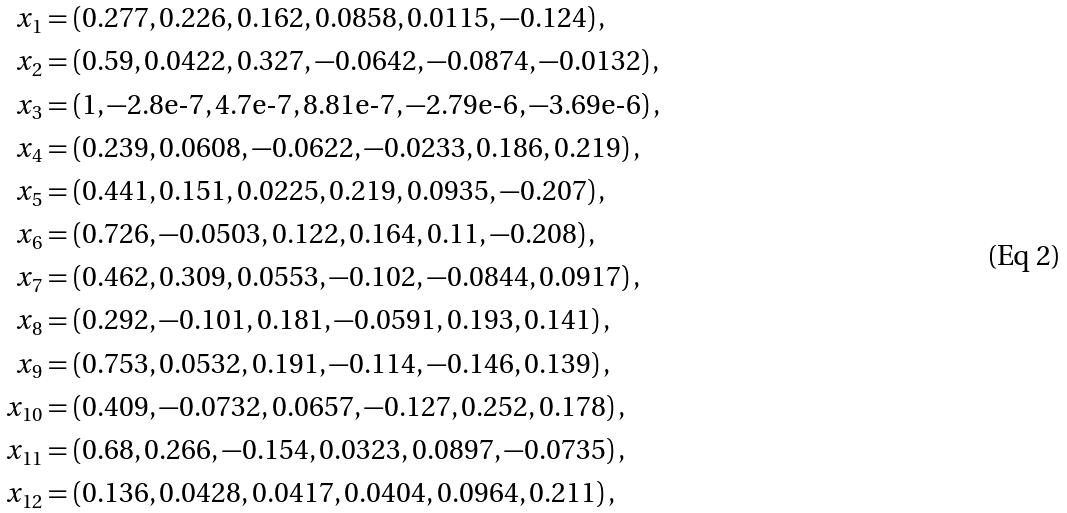<formula> <loc_0><loc_0><loc_500><loc_500>x _ { 1 } & = ( 0 . 2 7 7 , 0 . 2 2 6 , 0 . 1 6 2 , 0 . 0 8 5 8 , 0 . 0 1 1 5 , - 0 . 1 2 4 ) \, , \\ x _ { 2 } & = ( 0 . 5 9 , 0 . 0 4 2 2 , 0 . 3 2 7 , - 0 . 0 6 4 2 , - 0 . 0 8 7 4 , - 0 . 0 1 3 2 ) \, , \\ x _ { 3 } & = ( 1 , - 2 . 8 \text {e-7} , 4 . 7 \text {e-7} , 8 . 8 1 \text {e-7} , - 2 . 7 9 \text {e-6} , - 3 . 6 9 \text {e-6} ) \, , \\ x _ { 4 } & = ( 0 . 2 3 9 , 0 . 0 6 0 8 , - 0 . 0 6 2 2 , - 0 . 0 2 3 3 , 0 . 1 8 6 , 0 . 2 1 9 ) \, , \\ x _ { 5 } & = ( 0 . 4 4 1 , 0 . 1 5 1 , 0 . 0 2 2 5 , 0 . 2 1 9 , 0 . 0 9 3 5 , - 0 . 2 0 7 ) \, , \\ x _ { 6 } & = ( 0 . 7 2 6 , - 0 . 0 5 0 3 , 0 . 1 2 2 , 0 . 1 6 4 , 0 . 1 1 , - 0 . 2 0 8 ) \, , \\ x _ { 7 } & = ( 0 . 4 6 2 , 0 . 3 0 9 , 0 . 0 5 5 3 , - 0 . 1 0 2 , - 0 . 0 8 4 4 , 0 . 0 9 1 7 ) \, , \\ x _ { 8 } & = ( 0 . 2 9 2 , - 0 . 1 0 1 , 0 . 1 8 1 , - 0 . 0 5 9 1 , 0 . 1 9 3 , 0 . 1 4 1 ) \, , \\ x _ { 9 } & = ( 0 . 7 5 3 , 0 . 0 5 3 2 , 0 . 1 9 1 , - 0 . 1 1 4 , - 0 . 1 4 6 , 0 . 1 3 9 ) \, , \\ x _ { 1 0 } & = ( 0 . 4 0 9 , - 0 . 0 7 3 2 , 0 . 0 6 5 7 , - 0 . 1 2 7 , 0 . 2 5 2 , 0 . 1 7 8 ) \, , \\ x _ { 1 1 } & = ( 0 . 6 8 , 0 . 2 6 6 , - 0 . 1 5 4 , 0 . 0 3 2 3 , 0 . 0 8 9 7 , - 0 . 0 7 3 5 ) \, , \\ x _ { 1 2 } & = ( 0 . 1 3 6 , 0 . 0 4 2 8 , 0 . 0 4 1 7 , 0 . 0 4 0 4 , 0 . 0 9 6 4 , 0 . 2 1 1 ) \, ,</formula> 